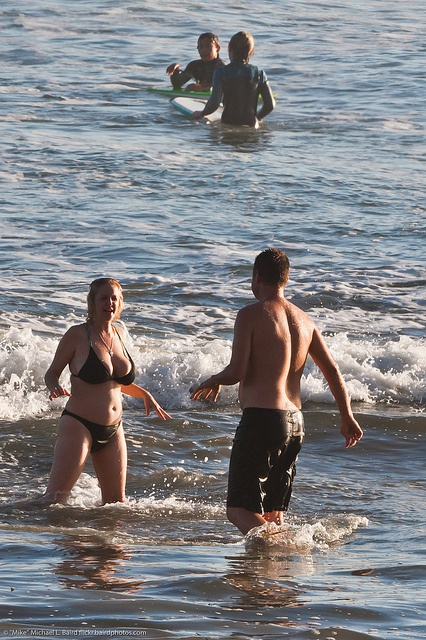Describe the objects in this image and their specific colors. I can see people in gray, black, maroon, and lightgray tones, people in gray, maroon, black, and lightgray tones, people in gray and black tones, people in gray and black tones, and surfboard in gray, lightgray, and darkgray tones in this image. 